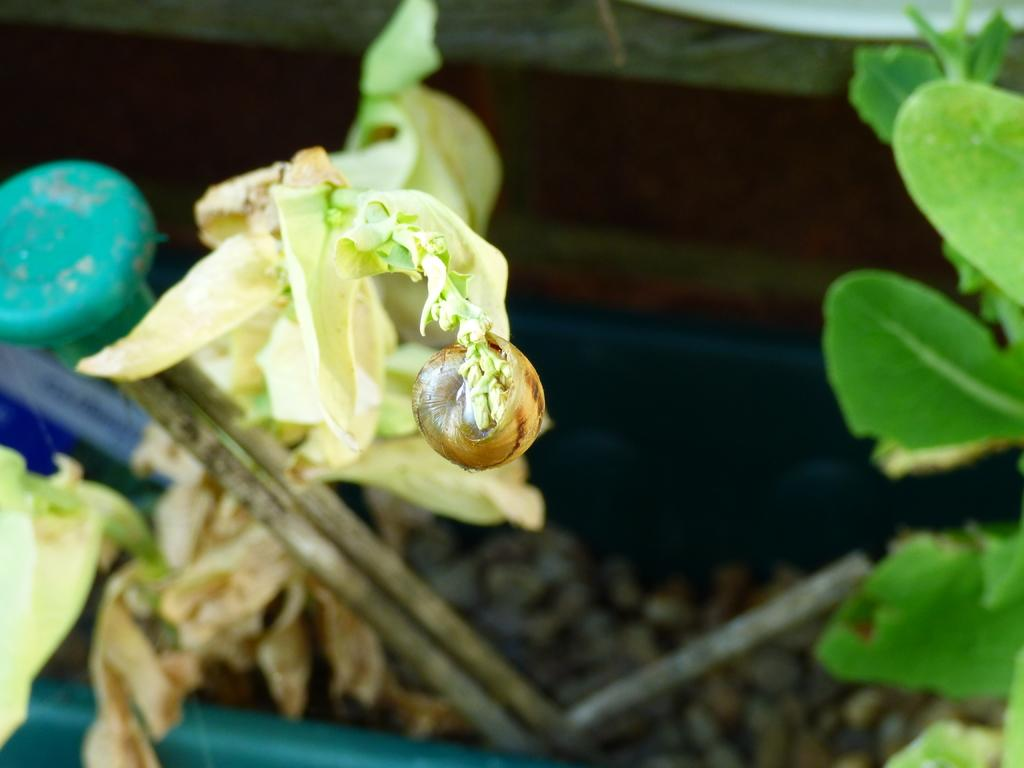What is present in the image? There is a plant in the image. What color is the plant? The plant is green in color. Can you describe anything in the background of the image? There are objects visible in the background of the image. How does the father interact with the plant in the image? There is no father present in the image, so it is not possible to answer that question. 